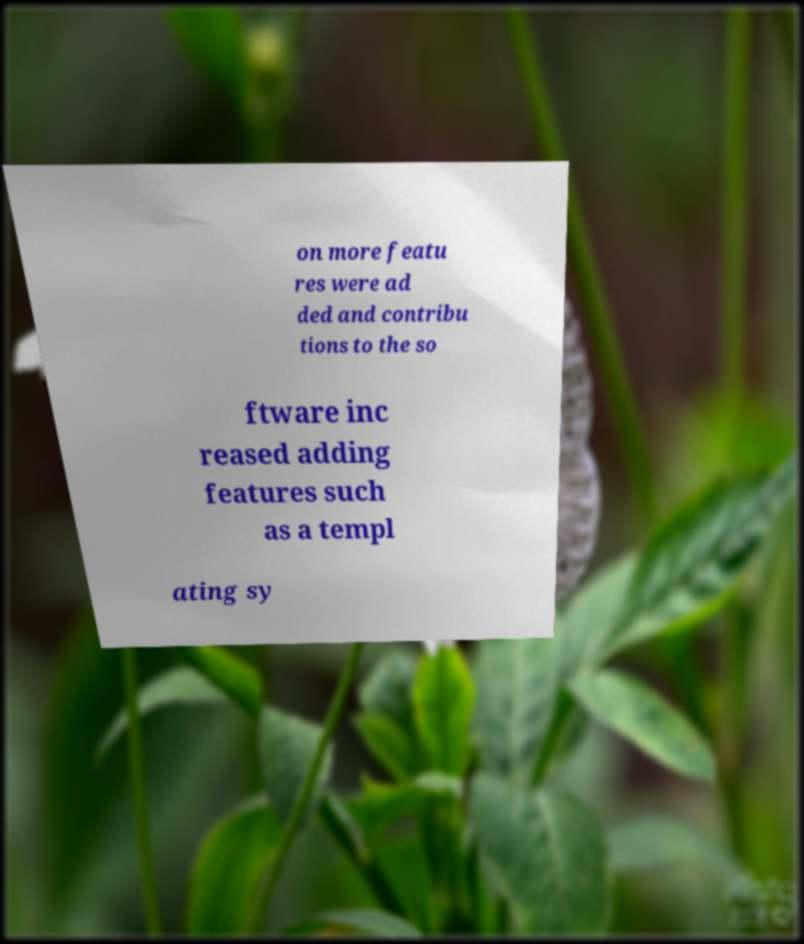Can you read and provide the text displayed in the image?This photo seems to have some interesting text. Can you extract and type it out for me? on more featu res were ad ded and contribu tions to the so ftware inc reased adding features such as a templ ating sy 